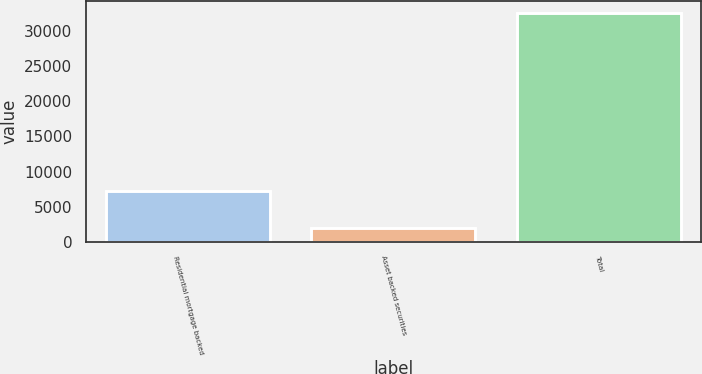Convert chart. <chart><loc_0><loc_0><loc_500><loc_500><bar_chart><fcel>Residential mortgage backed<fcel>Asset backed securities<fcel>Total<nl><fcel>7258<fcel>2020<fcel>32619<nl></chart> 